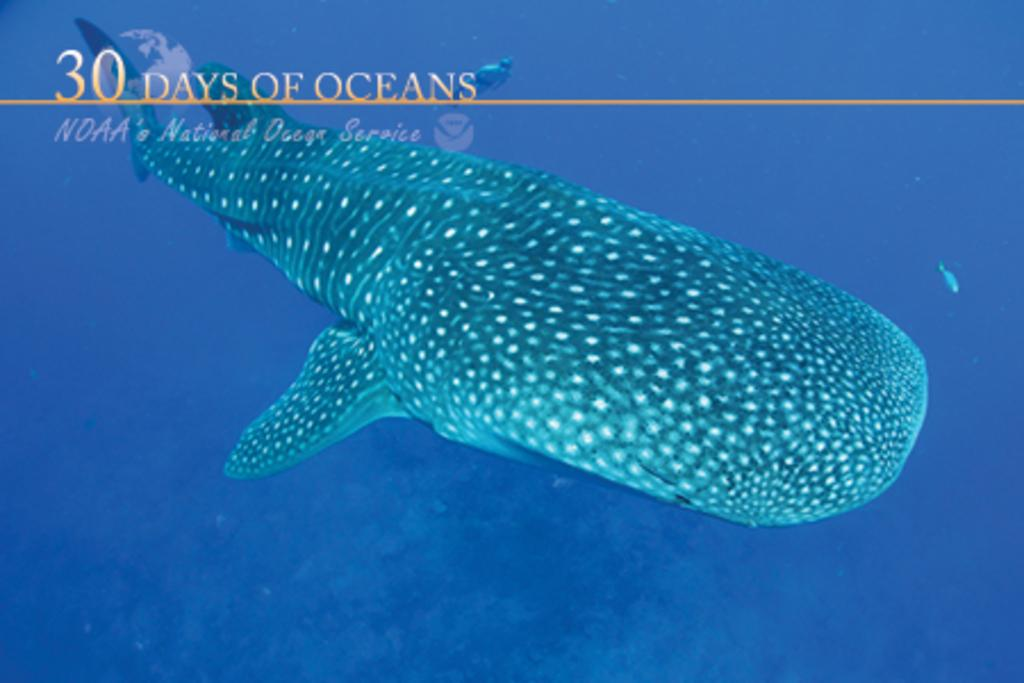What type of image is being described? The image is animated. What can be seen in the water in the image? There is a fish in the water. Where is the text located in the image? The text is on the left side top of the image. How many chairs are visible in the image? There are no chairs present in the image. What statement does the fish make in the image? The image is animated, but it does not contain any dialogue or statements from the fish. 